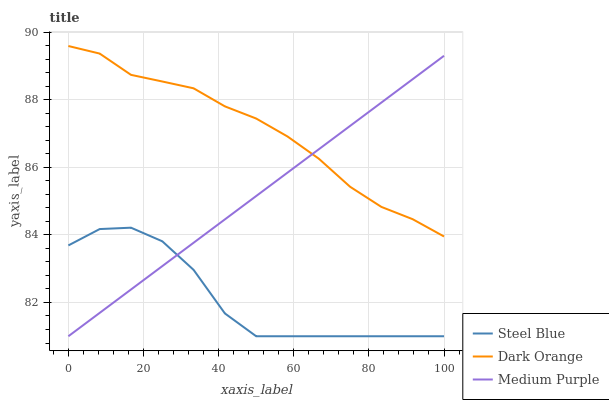Does Steel Blue have the minimum area under the curve?
Answer yes or no. Yes. Does Dark Orange have the maximum area under the curve?
Answer yes or no. Yes. Does Dark Orange have the minimum area under the curve?
Answer yes or no. No. Does Steel Blue have the maximum area under the curve?
Answer yes or no. No. Is Medium Purple the smoothest?
Answer yes or no. Yes. Is Steel Blue the roughest?
Answer yes or no. Yes. Is Dark Orange the smoothest?
Answer yes or no. No. Is Dark Orange the roughest?
Answer yes or no. No. Does Medium Purple have the lowest value?
Answer yes or no. Yes. Does Dark Orange have the lowest value?
Answer yes or no. No. Does Dark Orange have the highest value?
Answer yes or no. Yes. Does Steel Blue have the highest value?
Answer yes or no. No. Is Steel Blue less than Dark Orange?
Answer yes or no. Yes. Is Dark Orange greater than Steel Blue?
Answer yes or no. Yes. Does Medium Purple intersect Dark Orange?
Answer yes or no. Yes. Is Medium Purple less than Dark Orange?
Answer yes or no. No. Is Medium Purple greater than Dark Orange?
Answer yes or no. No. Does Steel Blue intersect Dark Orange?
Answer yes or no. No. 